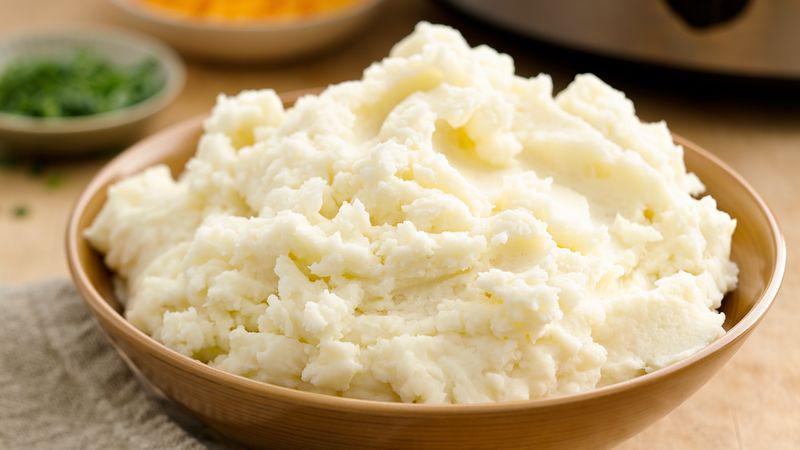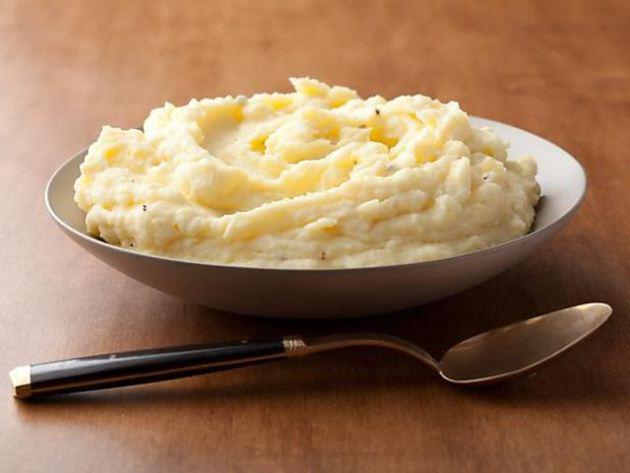The first image is the image on the left, the second image is the image on the right. Analyze the images presented: Is the assertion "One image shows mashed potatoes served in a lime-green bowl." valid? Answer yes or no. No. The first image is the image on the left, the second image is the image on the right. For the images displayed, is the sentence "There is a green bowl in one of the images" factually correct? Answer yes or no. No. The first image is the image on the left, the second image is the image on the right. Assess this claim about the two images: "A spoon is next to a bowl in at least one image.". Correct or not? Answer yes or no. Yes. 